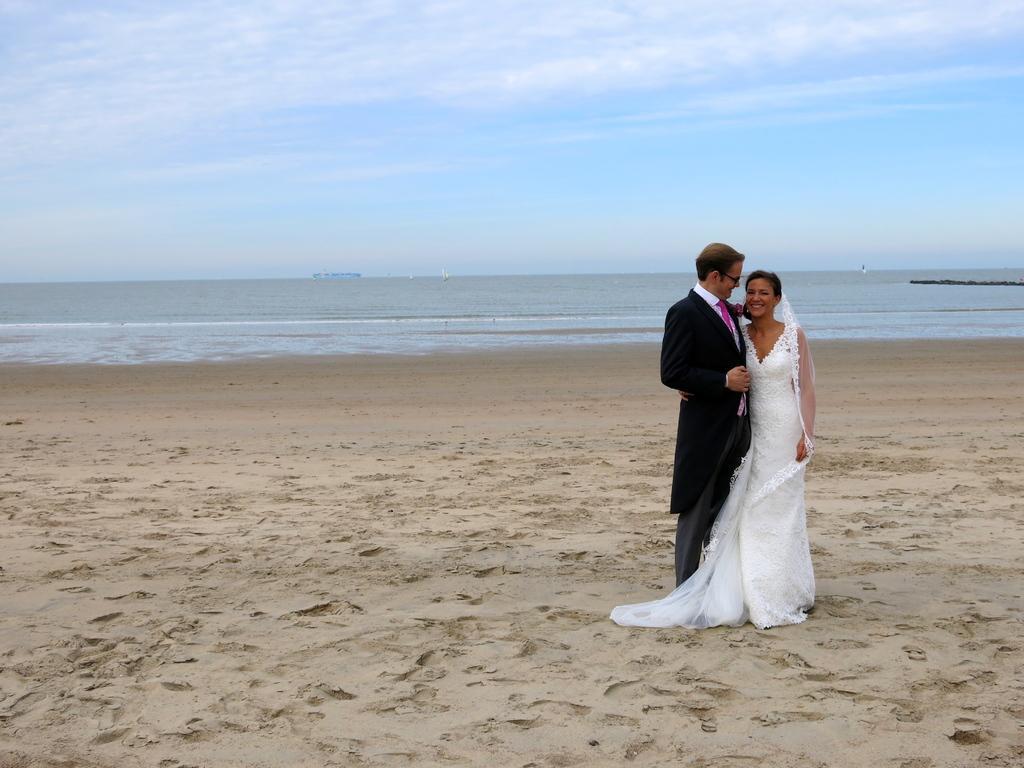Can you describe this image briefly? In this picture there is a man who is wearing suit, trouser and spectacle. Beside him there is a woman who is wearing white color dress. Both of them are standing on the beach. In the background I can see the ocean. At the top I can see the sky and clouds. 